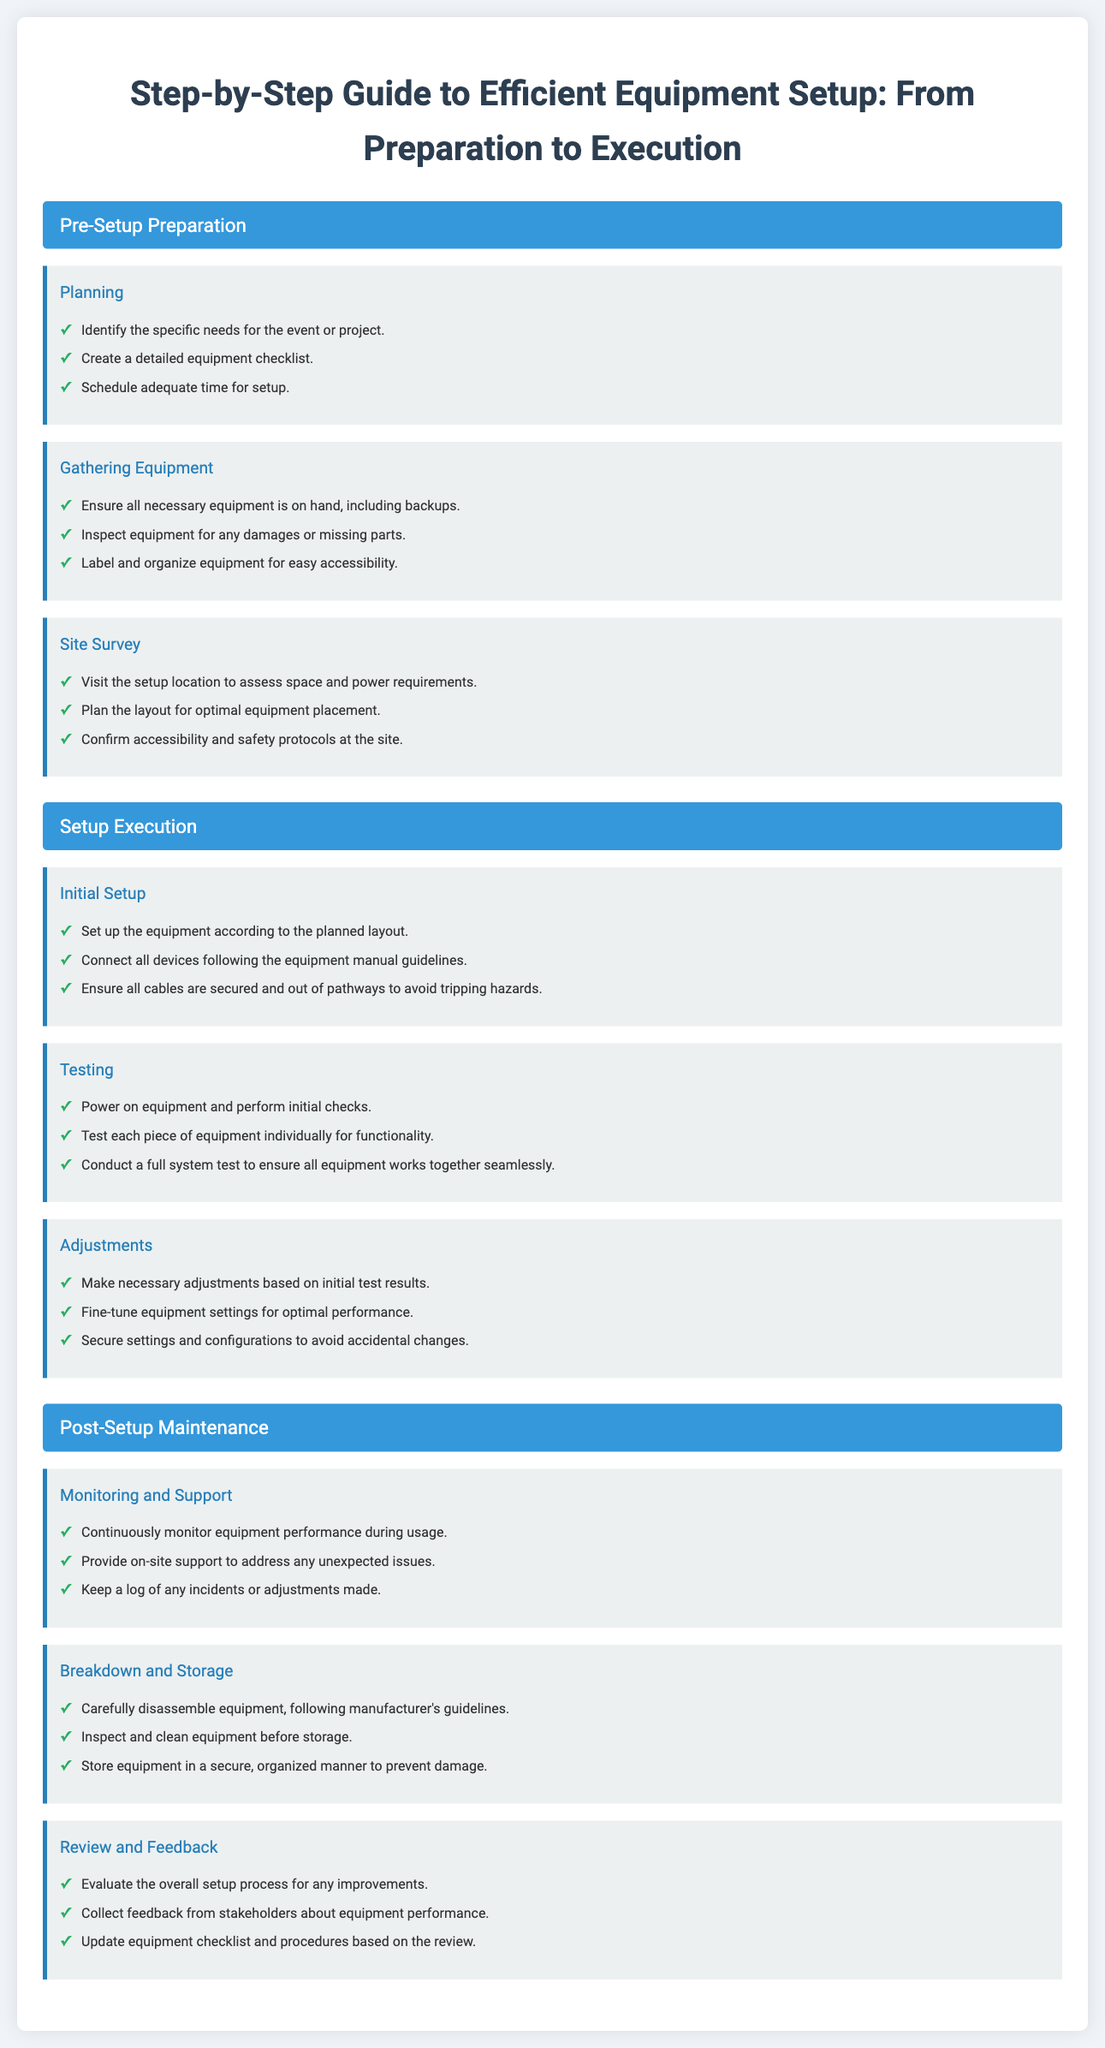What is the title of the guide? The title is located at the top of the document.
Answer: Step-by-Step Guide to Efficient Equipment Setup: From Preparation to Execution How many sections are in the guide? The document includes three main sections, which can be counted in the hierarchy.
Answer: Three What is the first item listed under "Planning"? The first item is the first point in the Planning subsection.
Answer: Identify the specific needs for the event or project What should be secured to avoid tripping hazards? This information is found in the Initial Setup subsection.
Answer: All cables What is a key activity during "Monitoring and Support"? This point is related to the continuous activities described under this subsection.
Answer: Continuously monitor equipment performance during usage How many subsections are under "Post-Setup Maintenance"? The document provides a list of subsections under this section.
Answer: Three What is the last point in the "Review and Feedback" subsection? This information is extracted from the last item listed in the Review and Feedback section.
Answer: Update equipment checklist and procedures based on the review What should be done with equipment before storage? This action is described in the Breakdown and Storage subsection.
Answer: Inspect and clean equipment before storage Which section includes information about testing equipment? This can be found in a specific phase of setup management.
Answer: Setup Execution 